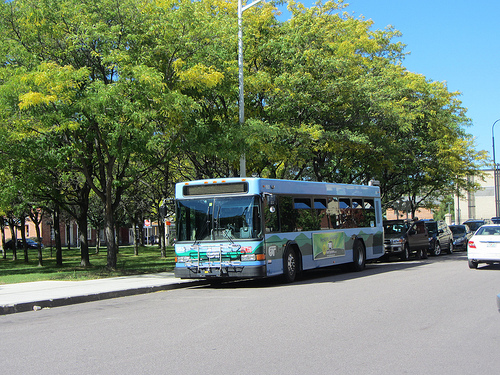What is before the tree? A bus is positioned before the tree. 